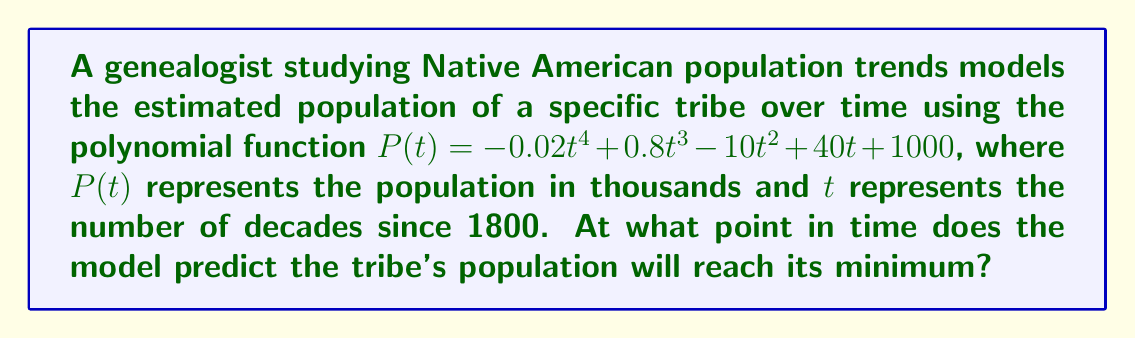Help me with this question. To find the minimum point of the population function, we need to follow these steps:

1) First, we need to find the derivative of $P(t)$:
   $P'(t) = -0.08t^3 + 2.4t^2 - 20t + 40$

2) To find the critical points, we set $P'(t) = 0$:
   $-0.08t^3 + 2.4t^2 - 20t + 40 = 0$

3) This is a cubic equation. While it can be solved algebraically, it's complex. In practice, we would use numerical methods or graphing calculators. Let's assume we've found the solutions:
   $t \approx 1.78, 8.22, 20$

4) To determine which of these critical points is the minimum, we can use the second derivative test:
   $P''(t) = -0.24t^2 + 4.8t - 20$

5) Evaluating $P''(t)$ at each critical point:
   $P''(1.78) \approx -13.5$ (negative, local maximum)
   $P''(8.22) \approx 13.5$ (positive, local minimum)
   $P''(20) \approx -20$ (negative, local maximum)

6) The minimum occurs at $t \approx 8.22$ decades after 1800.

7) To convert this to a year:
   1800 + (8.22 * 10) ≈ 1882

Therefore, the model predicts the tribe's population will reach its minimum around 1882.
Answer: 1882 